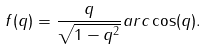Convert formula to latex. <formula><loc_0><loc_0><loc_500><loc_500>f ( q ) = \frac { q } { \sqrt { 1 - q ^ { 2 } } } a r c \cos ( q ) .</formula> 